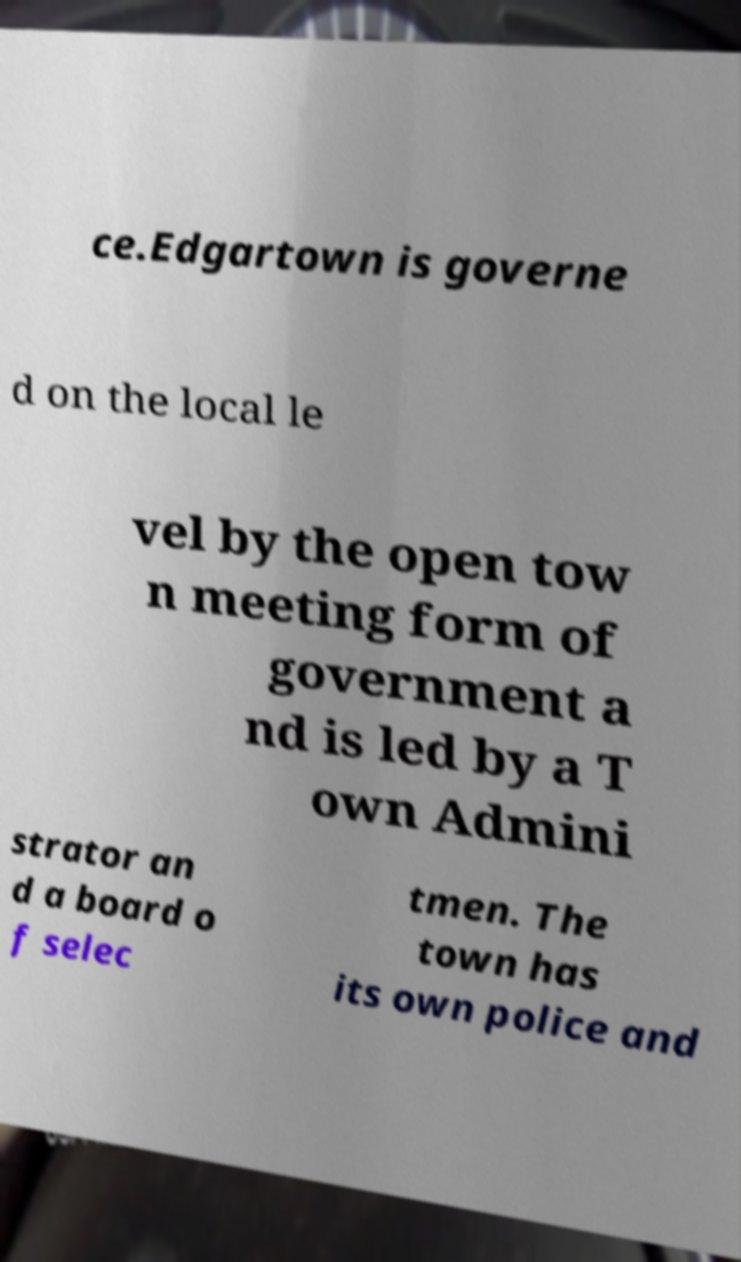Could you extract and type out the text from this image? ce.Edgartown is governe d on the local le vel by the open tow n meeting form of government a nd is led by a T own Admini strator an d a board o f selec tmen. The town has its own police and 